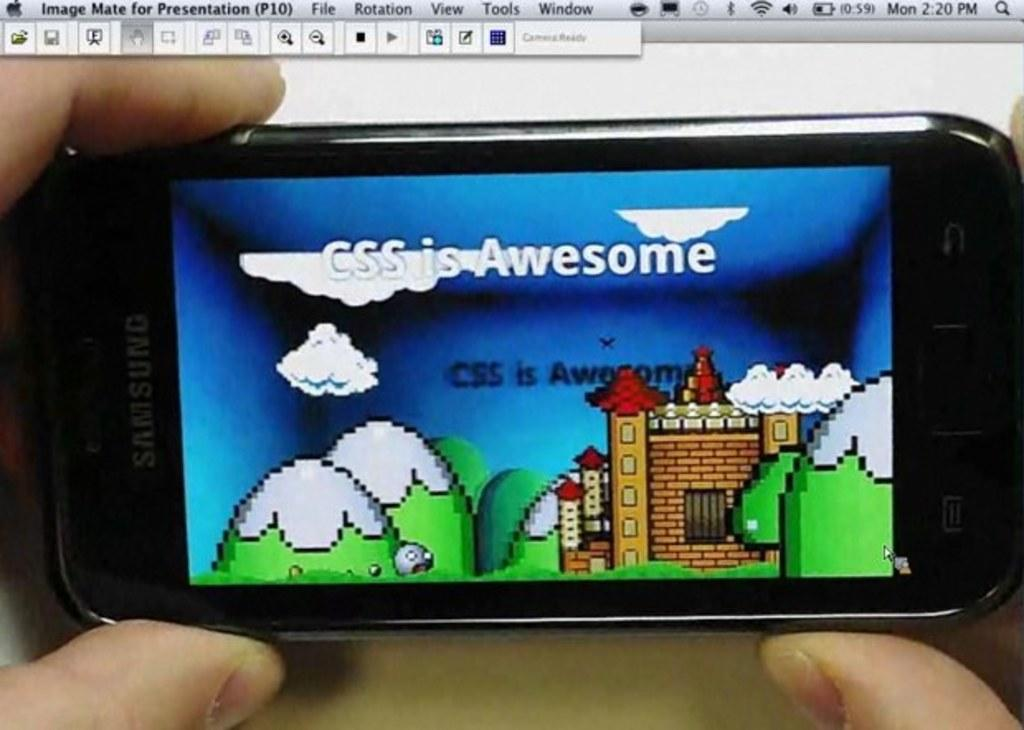Who is in the image? There is a person in the image. What is the person holding in the image? The person is holding a mobile phone. What can be seen on the mobile phone's screen? The mobile phone has a picture displayed on it. Can you describe the object above the mobile phone? There is an object above the mobile phone, but its description is not provided in the facts. What type of food is being prepared in the vessel in the image? There is no vessel or food present in the image. 